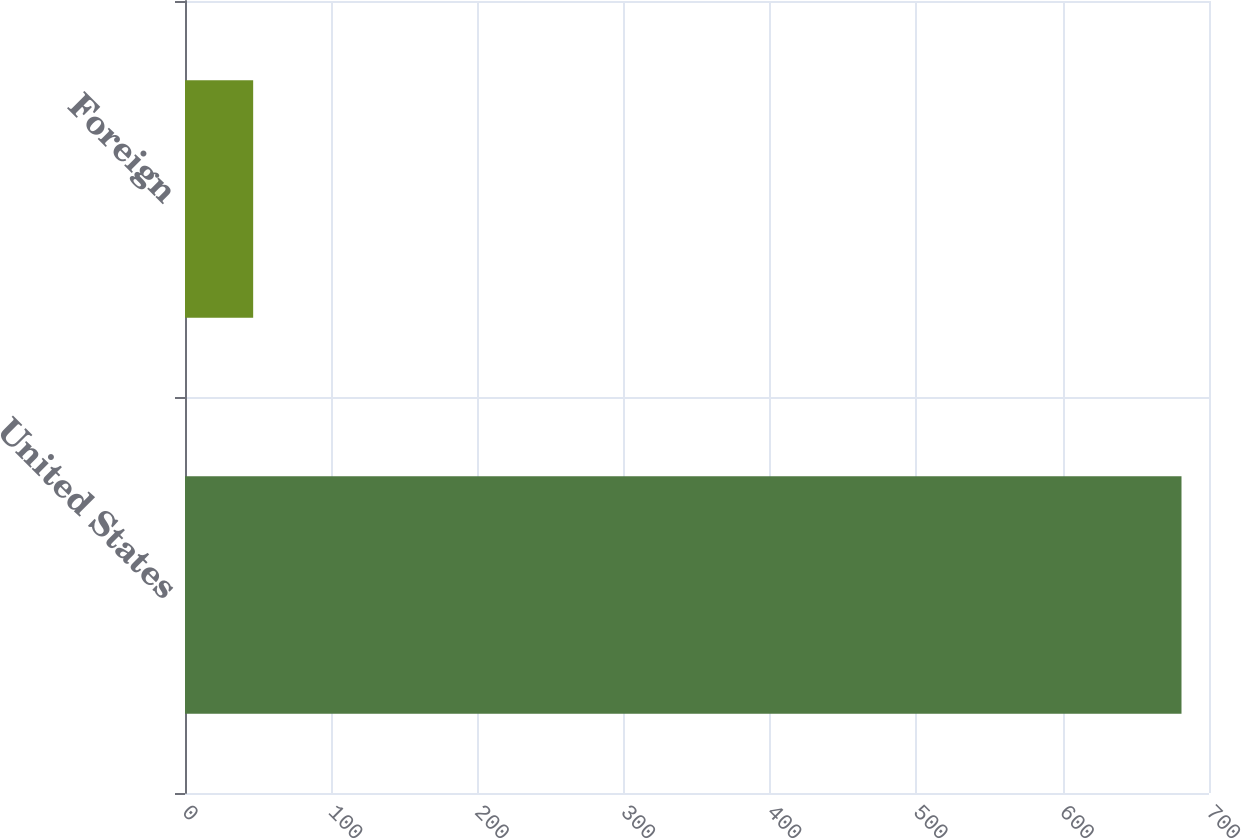<chart> <loc_0><loc_0><loc_500><loc_500><bar_chart><fcel>United States<fcel>Foreign<nl><fcel>681.2<fcel>46.6<nl></chart> 